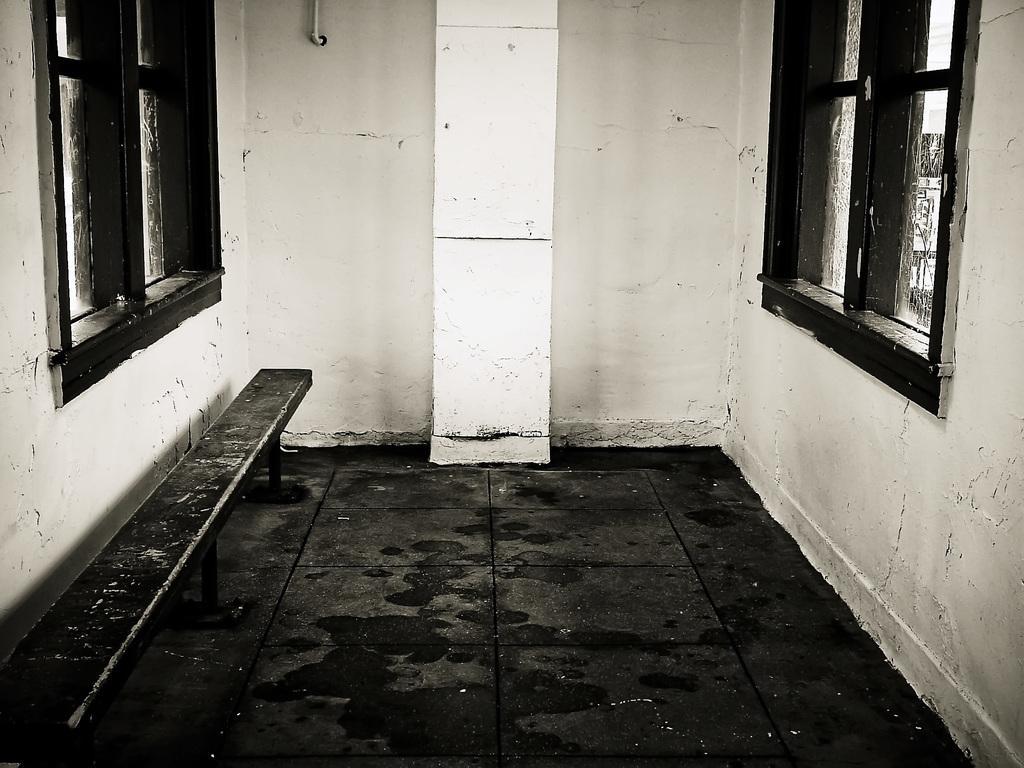Could you give a brief overview of what you see in this image? In this image, we can see the ground and a metal bench. We can see the wall with some windows and objects. 